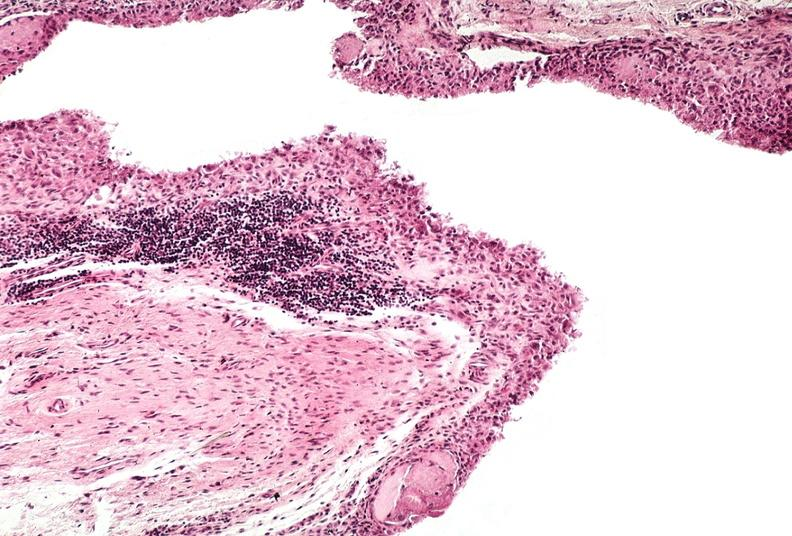does cranial artery show synovial proliferation, villous, rheumatoid arthritis?
Answer the question using a single word or phrase. No 